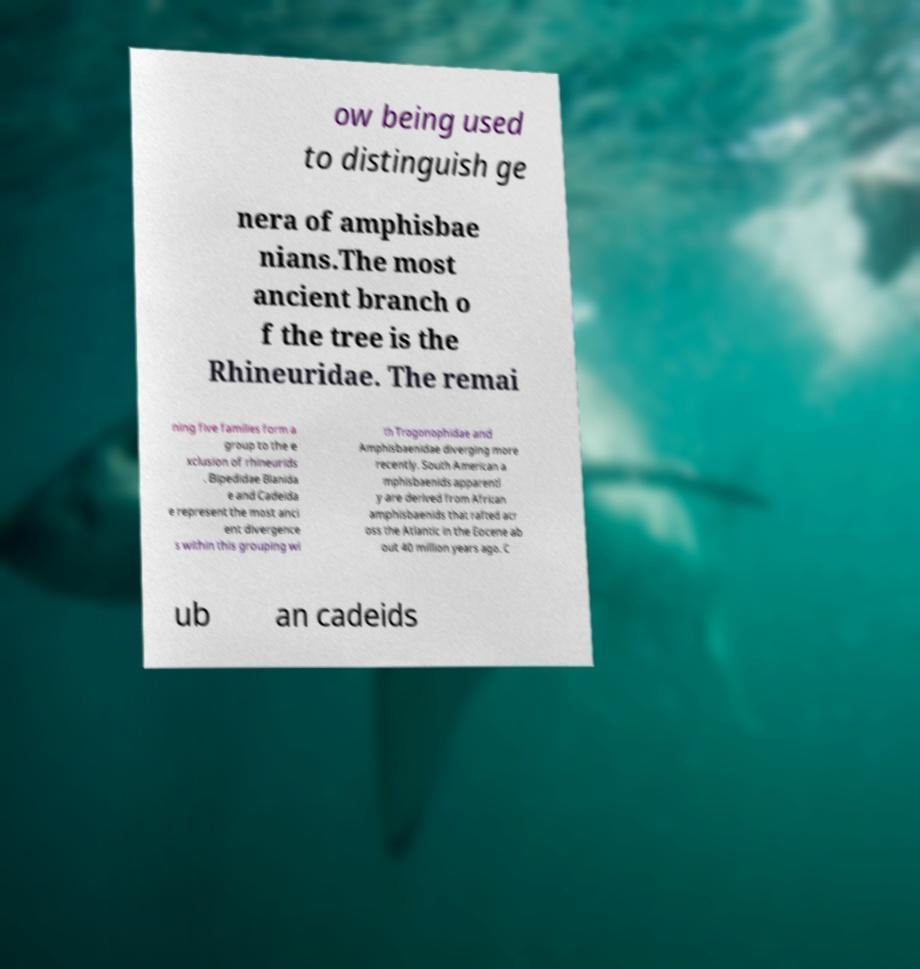Could you extract and type out the text from this image? ow being used to distinguish ge nera of amphisbae nians.The most ancient branch o f the tree is the Rhineuridae. The remai ning five families form a group to the e xclusion of rhineurids . Bipedidae Blanida e and Cadeida e represent the most anci ent divergence s within this grouping wi th Trogonophidae and Amphisbaenidae diverging more recently. South American a mphisbaenids apparentl y are derived from African amphisbaenids that rafted acr oss the Atlantic in the Eocene ab out 40 million years ago. C ub an cadeids 